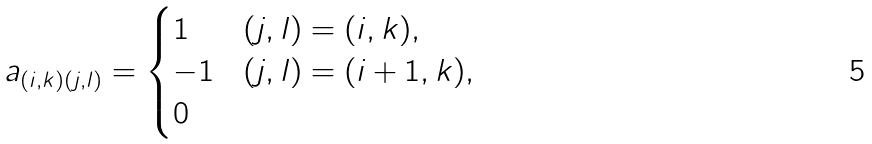<formula> <loc_0><loc_0><loc_500><loc_500>a _ { ( i , k ) ( j , l ) } = \begin{cases} 1 & ( j , l ) = ( i , k ) , \\ - 1 & ( j , l ) = ( i + 1 , k ) , \\ 0 & \end{cases}</formula> 